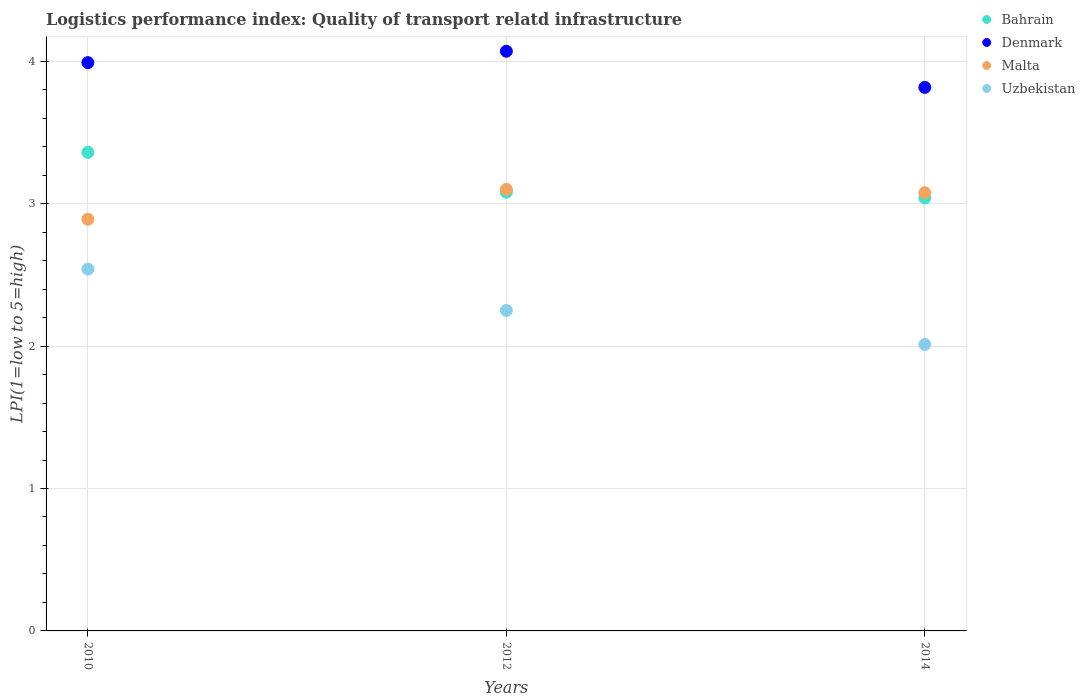What is the logistics performance index in Bahrain in 2012?
Make the answer very short. 3.08. Across all years, what is the minimum logistics performance index in Bahrain?
Provide a succinct answer. 3.04. In which year was the logistics performance index in Bahrain maximum?
Keep it short and to the point. 2010. In which year was the logistics performance index in Denmark minimum?
Ensure brevity in your answer.  2014. What is the total logistics performance index in Bahrain in the graph?
Provide a succinct answer. 9.48. What is the difference between the logistics performance index in Denmark in 2012 and that in 2014?
Provide a succinct answer. 0.25. What is the difference between the logistics performance index in Malta in 2014 and the logistics performance index in Uzbekistan in 2012?
Provide a short and direct response. 0.83. What is the average logistics performance index in Bahrain per year?
Offer a terse response. 3.16. In the year 2012, what is the difference between the logistics performance index in Uzbekistan and logistics performance index in Malta?
Provide a succinct answer. -0.85. What is the ratio of the logistics performance index in Uzbekistan in 2010 to that in 2014?
Your answer should be very brief. 1.26. Is the logistics performance index in Malta in 2012 less than that in 2014?
Your answer should be compact. No. Is the difference between the logistics performance index in Uzbekistan in 2010 and 2012 greater than the difference between the logistics performance index in Malta in 2010 and 2012?
Give a very brief answer. Yes. What is the difference between the highest and the second highest logistics performance index in Denmark?
Offer a terse response. 0.08. What is the difference between the highest and the lowest logistics performance index in Uzbekistan?
Make the answer very short. 0.53. In how many years, is the logistics performance index in Malta greater than the average logistics performance index in Malta taken over all years?
Your response must be concise. 2. Is it the case that in every year, the sum of the logistics performance index in Uzbekistan and logistics performance index in Malta  is greater than the sum of logistics performance index in Bahrain and logistics performance index in Denmark?
Make the answer very short. No. Is it the case that in every year, the sum of the logistics performance index in Bahrain and logistics performance index in Uzbekistan  is greater than the logistics performance index in Denmark?
Provide a short and direct response. Yes. Does the logistics performance index in Bahrain monotonically increase over the years?
Make the answer very short. No. Is the logistics performance index in Denmark strictly greater than the logistics performance index in Uzbekistan over the years?
Give a very brief answer. Yes. Is the logistics performance index in Uzbekistan strictly less than the logistics performance index in Bahrain over the years?
Ensure brevity in your answer.  Yes. What is the difference between two consecutive major ticks on the Y-axis?
Keep it short and to the point. 1. How are the legend labels stacked?
Offer a terse response. Vertical. What is the title of the graph?
Your answer should be very brief. Logistics performance index: Quality of transport relatd infrastructure. Does "Ghana" appear as one of the legend labels in the graph?
Ensure brevity in your answer.  No. What is the label or title of the Y-axis?
Give a very brief answer. LPI(1=low to 5=high). What is the LPI(1=low to 5=high) of Bahrain in 2010?
Your answer should be compact. 3.36. What is the LPI(1=low to 5=high) of Denmark in 2010?
Make the answer very short. 3.99. What is the LPI(1=low to 5=high) in Malta in 2010?
Make the answer very short. 2.89. What is the LPI(1=low to 5=high) in Uzbekistan in 2010?
Your answer should be very brief. 2.54. What is the LPI(1=low to 5=high) of Bahrain in 2012?
Your answer should be compact. 3.08. What is the LPI(1=low to 5=high) of Denmark in 2012?
Make the answer very short. 4.07. What is the LPI(1=low to 5=high) in Uzbekistan in 2012?
Your answer should be compact. 2.25. What is the LPI(1=low to 5=high) in Bahrain in 2014?
Give a very brief answer. 3.04. What is the LPI(1=low to 5=high) in Denmark in 2014?
Ensure brevity in your answer.  3.82. What is the LPI(1=low to 5=high) of Malta in 2014?
Keep it short and to the point. 3.08. What is the LPI(1=low to 5=high) in Uzbekistan in 2014?
Provide a short and direct response. 2.01. Across all years, what is the maximum LPI(1=low to 5=high) in Bahrain?
Provide a short and direct response. 3.36. Across all years, what is the maximum LPI(1=low to 5=high) of Denmark?
Offer a very short reply. 4.07. Across all years, what is the maximum LPI(1=low to 5=high) of Uzbekistan?
Keep it short and to the point. 2.54. Across all years, what is the minimum LPI(1=low to 5=high) of Bahrain?
Your answer should be compact. 3.04. Across all years, what is the minimum LPI(1=low to 5=high) of Denmark?
Provide a short and direct response. 3.82. Across all years, what is the minimum LPI(1=low to 5=high) in Malta?
Your answer should be very brief. 2.89. Across all years, what is the minimum LPI(1=low to 5=high) in Uzbekistan?
Offer a terse response. 2.01. What is the total LPI(1=low to 5=high) in Bahrain in the graph?
Ensure brevity in your answer.  9.48. What is the total LPI(1=low to 5=high) of Denmark in the graph?
Offer a very short reply. 11.88. What is the total LPI(1=low to 5=high) of Malta in the graph?
Make the answer very short. 9.07. What is the total LPI(1=low to 5=high) in Uzbekistan in the graph?
Provide a succinct answer. 6.8. What is the difference between the LPI(1=low to 5=high) in Bahrain in 2010 and that in 2012?
Your response must be concise. 0.28. What is the difference between the LPI(1=low to 5=high) of Denmark in 2010 and that in 2012?
Provide a short and direct response. -0.08. What is the difference between the LPI(1=low to 5=high) in Malta in 2010 and that in 2012?
Your response must be concise. -0.21. What is the difference between the LPI(1=low to 5=high) in Uzbekistan in 2010 and that in 2012?
Provide a short and direct response. 0.29. What is the difference between the LPI(1=low to 5=high) of Bahrain in 2010 and that in 2014?
Provide a short and direct response. 0.32. What is the difference between the LPI(1=low to 5=high) of Denmark in 2010 and that in 2014?
Offer a very short reply. 0.17. What is the difference between the LPI(1=low to 5=high) of Malta in 2010 and that in 2014?
Offer a very short reply. -0.19. What is the difference between the LPI(1=low to 5=high) of Uzbekistan in 2010 and that in 2014?
Your response must be concise. 0.53. What is the difference between the LPI(1=low to 5=high) of Bahrain in 2012 and that in 2014?
Your answer should be compact. 0.04. What is the difference between the LPI(1=low to 5=high) in Denmark in 2012 and that in 2014?
Provide a succinct answer. 0.25. What is the difference between the LPI(1=low to 5=high) of Malta in 2012 and that in 2014?
Ensure brevity in your answer.  0.02. What is the difference between the LPI(1=low to 5=high) of Uzbekistan in 2012 and that in 2014?
Make the answer very short. 0.24. What is the difference between the LPI(1=low to 5=high) of Bahrain in 2010 and the LPI(1=low to 5=high) of Denmark in 2012?
Your answer should be compact. -0.71. What is the difference between the LPI(1=low to 5=high) in Bahrain in 2010 and the LPI(1=low to 5=high) in Malta in 2012?
Your response must be concise. 0.26. What is the difference between the LPI(1=low to 5=high) of Bahrain in 2010 and the LPI(1=low to 5=high) of Uzbekistan in 2012?
Your answer should be compact. 1.11. What is the difference between the LPI(1=low to 5=high) of Denmark in 2010 and the LPI(1=low to 5=high) of Malta in 2012?
Keep it short and to the point. 0.89. What is the difference between the LPI(1=low to 5=high) of Denmark in 2010 and the LPI(1=low to 5=high) of Uzbekistan in 2012?
Give a very brief answer. 1.74. What is the difference between the LPI(1=low to 5=high) in Malta in 2010 and the LPI(1=low to 5=high) in Uzbekistan in 2012?
Offer a terse response. 0.64. What is the difference between the LPI(1=low to 5=high) in Bahrain in 2010 and the LPI(1=low to 5=high) in Denmark in 2014?
Your response must be concise. -0.46. What is the difference between the LPI(1=low to 5=high) of Bahrain in 2010 and the LPI(1=low to 5=high) of Malta in 2014?
Your response must be concise. 0.28. What is the difference between the LPI(1=low to 5=high) of Bahrain in 2010 and the LPI(1=low to 5=high) of Uzbekistan in 2014?
Your response must be concise. 1.35. What is the difference between the LPI(1=low to 5=high) in Denmark in 2010 and the LPI(1=low to 5=high) in Malta in 2014?
Make the answer very short. 0.91. What is the difference between the LPI(1=low to 5=high) of Denmark in 2010 and the LPI(1=low to 5=high) of Uzbekistan in 2014?
Your answer should be compact. 1.98. What is the difference between the LPI(1=low to 5=high) of Malta in 2010 and the LPI(1=low to 5=high) of Uzbekistan in 2014?
Your answer should be very brief. 0.88. What is the difference between the LPI(1=low to 5=high) in Bahrain in 2012 and the LPI(1=low to 5=high) in Denmark in 2014?
Your response must be concise. -0.74. What is the difference between the LPI(1=low to 5=high) in Bahrain in 2012 and the LPI(1=low to 5=high) in Malta in 2014?
Give a very brief answer. 0. What is the difference between the LPI(1=low to 5=high) in Bahrain in 2012 and the LPI(1=low to 5=high) in Uzbekistan in 2014?
Your answer should be very brief. 1.07. What is the difference between the LPI(1=low to 5=high) in Denmark in 2012 and the LPI(1=low to 5=high) in Uzbekistan in 2014?
Provide a short and direct response. 2.06. What is the difference between the LPI(1=low to 5=high) of Malta in 2012 and the LPI(1=low to 5=high) of Uzbekistan in 2014?
Keep it short and to the point. 1.09. What is the average LPI(1=low to 5=high) of Bahrain per year?
Give a very brief answer. 3.16. What is the average LPI(1=low to 5=high) of Denmark per year?
Your response must be concise. 3.96. What is the average LPI(1=low to 5=high) of Malta per year?
Provide a short and direct response. 3.02. What is the average LPI(1=low to 5=high) in Uzbekistan per year?
Provide a short and direct response. 2.27. In the year 2010, what is the difference between the LPI(1=low to 5=high) in Bahrain and LPI(1=low to 5=high) in Denmark?
Ensure brevity in your answer.  -0.63. In the year 2010, what is the difference between the LPI(1=low to 5=high) in Bahrain and LPI(1=low to 5=high) in Malta?
Provide a succinct answer. 0.47. In the year 2010, what is the difference between the LPI(1=low to 5=high) in Bahrain and LPI(1=low to 5=high) in Uzbekistan?
Provide a succinct answer. 0.82. In the year 2010, what is the difference between the LPI(1=low to 5=high) in Denmark and LPI(1=low to 5=high) in Uzbekistan?
Ensure brevity in your answer.  1.45. In the year 2010, what is the difference between the LPI(1=low to 5=high) in Malta and LPI(1=low to 5=high) in Uzbekistan?
Give a very brief answer. 0.35. In the year 2012, what is the difference between the LPI(1=low to 5=high) in Bahrain and LPI(1=low to 5=high) in Denmark?
Provide a succinct answer. -0.99. In the year 2012, what is the difference between the LPI(1=low to 5=high) of Bahrain and LPI(1=low to 5=high) of Malta?
Keep it short and to the point. -0.02. In the year 2012, what is the difference between the LPI(1=low to 5=high) in Bahrain and LPI(1=low to 5=high) in Uzbekistan?
Offer a terse response. 0.83. In the year 2012, what is the difference between the LPI(1=low to 5=high) in Denmark and LPI(1=low to 5=high) in Malta?
Ensure brevity in your answer.  0.97. In the year 2012, what is the difference between the LPI(1=low to 5=high) in Denmark and LPI(1=low to 5=high) in Uzbekistan?
Your answer should be compact. 1.82. In the year 2014, what is the difference between the LPI(1=low to 5=high) in Bahrain and LPI(1=low to 5=high) in Denmark?
Your answer should be very brief. -0.78. In the year 2014, what is the difference between the LPI(1=low to 5=high) in Bahrain and LPI(1=low to 5=high) in Malta?
Your response must be concise. -0.04. In the year 2014, what is the difference between the LPI(1=low to 5=high) of Bahrain and LPI(1=low to 5=high) of Uzbekistan?
Offer a very short reply. 1.03. In the year 2014, what is the difference between the LPI(1=low to 5=high) of Denmark and LPI(1=low to 5=high) of Malta?
Provide a succinct answer. 0.74. In the year 2014, what is the difference between the LPI(1=low to 5=high) of Denmark and LPI(1=low to 5=high) of Uzbekistan?
Offer a terse response. 1.81. In the year 2014, what is the difference between the LPI(1=low to 5=high) of Malta and LPI(1=low to 5=high) of Uzbekistan?
Make the answer very short. 1.07. What is the ratio of the LPI(1=low to 5=high) in Denmark in 2010 to that in 2012?
Provide a short and direct response. 0.98. What is the ratio of the LPI(1=low to 5=high) of Malta in 2010 to that in 2012?
Offer a very short reply. 0.93. What is the ratio of the LPI(1=low to 5=high) in Uzbekistan in 2010 to that in 2012?
Your answer should be very brief. 1.13. What is the ratio of the LPI(1=low to 5=high) of Bahrain in 2010 to that in 2014?
Give a very brief answer. 1.11. What is the ratio of the LPI(1=low to 5=high) in Denmark in 2010 to that in 2014?
Provide a short and direct response. 1.05. What is the ratio of the LPI(1=low to 5=high) in Malta in 2010 to that in 2014?
Your response must be concise. 0.94. What is the ratio of the LPI(1=low to 5=high) of Uzbekistan in 2010 to that in 2014?
Make the answer very short. 1.26. What is the ratio of the LPI(1=low to 5=high) in Bahrain in 2012 to that in 2014?
Ensure brevity in your answer.  1.01. What is the ratio of the LPI(1=low to 5=high) of Denmark in 2012 to that in 2014?
Ensure brevity in your answer.  1.07. What is the ratio of the LPI(1=low to 5=high) in Malta in 2012 to that in 2014?
Offer a very short reply. 1.01. What is the ratio of the LPI(1=low to 5=high) of Uzbekistan in 2012 to that in 2014?
Ensure brevity in your answer.  1.12. What is the difference between the highest and the second highest LPI(1=low to 5=high) of Bahrain?
Offer a very short reply. 0.28. What is the difference between the highest and the second highest LPI(1=low to 5=high) in Malta?
Offer a very short reply. 0.02. What is the difference between the highest and the second highest LPI(1=low to 5=high) in Uzbekistan?
Ensure brevity in your answer.  0.29. What is the difference between the highest and the lowest LPI(1=low to 5=high) of Bahrain?
Offer a very short reply. 0.32. What is the difference between the highest and the lowest LPI(1=low to 5=high) in Denmark?
Make the answer very short. 0.25. What is the difference between the highest and the lowest LPI(1=low to 5=high) of Malta?
Your answer should be compact. 0.21. What is the difference between the highest and the lowest LPI(1=low to 5=high) of Uzbekistan?
Provide a succinct answer. 0.53. 